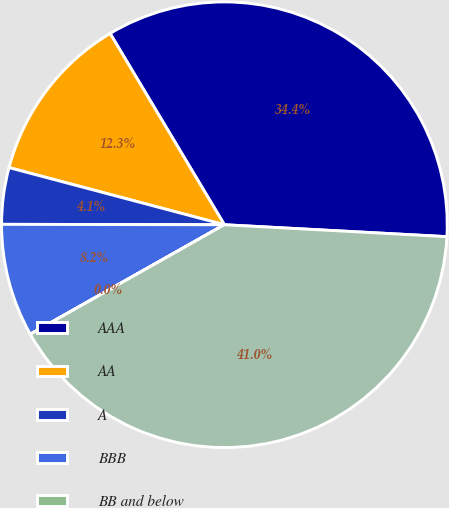Convert chart. <chart><loc_0><loc_0><loc_500><loc_500><pie_chart><fcel>AAA<fcel>AA<fcel>A<fcel>BBB<fcel>BB and below<fcel>Total(4)<nl><fcel>34.43%<fcel>12.3%<fcel>4.1%<fcel>8.2%<fcel>0.01%<fcel>40.97%<nl></chart> 